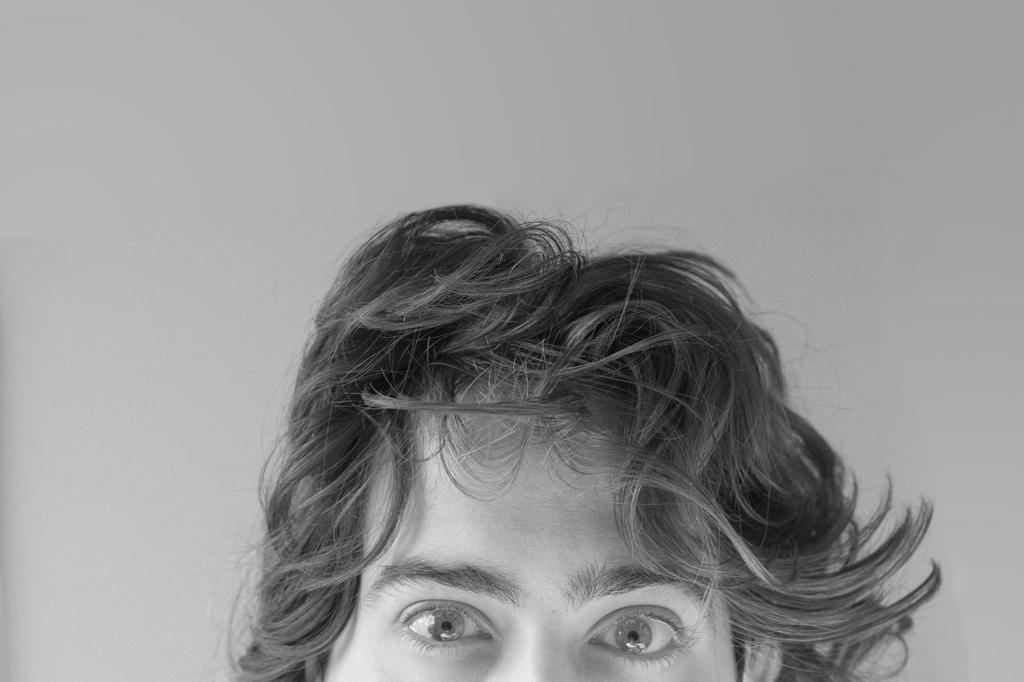What is the color scheme of the image? The image is black and white. What can be seen in the background of the image? The background of the image is gray in color. What is the main subject of the image? There is a face of a person in the middle of the image. How loud is the sea in the image? There is no sea present in the image, so it is not possible to determine its volume. 